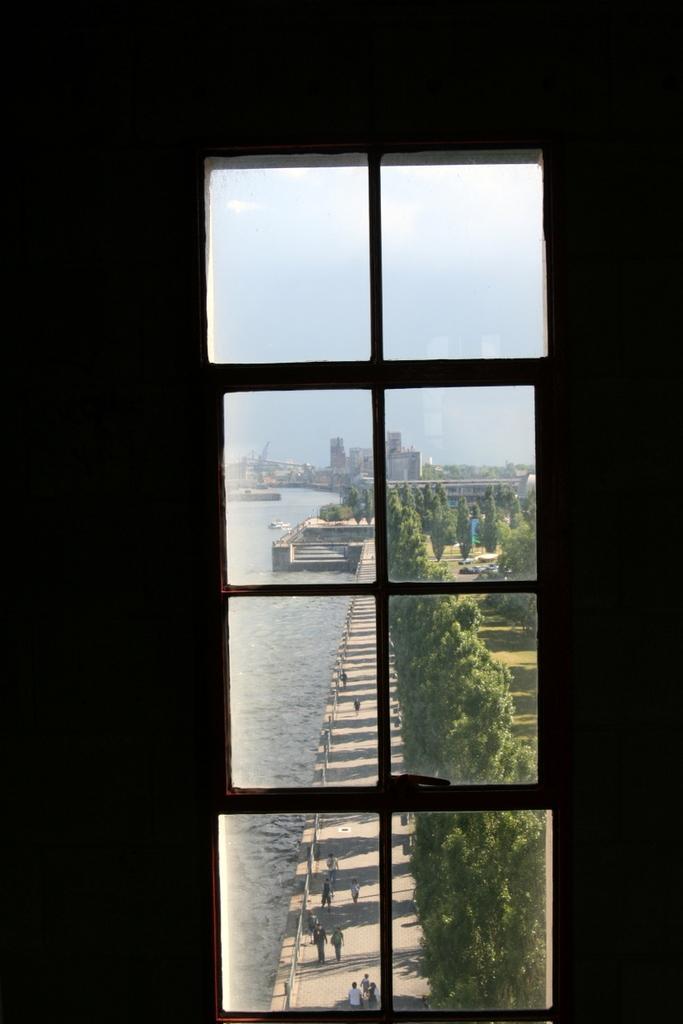What can be seen in the image that allows us to view the outside? There is a window in the image. What natural element is visible in the image? There is a water body visible in the image. What type of vegetation is present in the image? There is a group of trees in the image. What are the people in the image doing? There are people on the ground in the image. What type of man-made structures can be seen in the image? There are buildings in the image. What is visible above the structures and vegetation in the image? The sky is visible in the image. Where is the cobweb located in the image? There is no cobweb present in the image. What advice can be given to the people in the image? We cannot provide advice to the people in the image, as we do not know their situation or needs. 